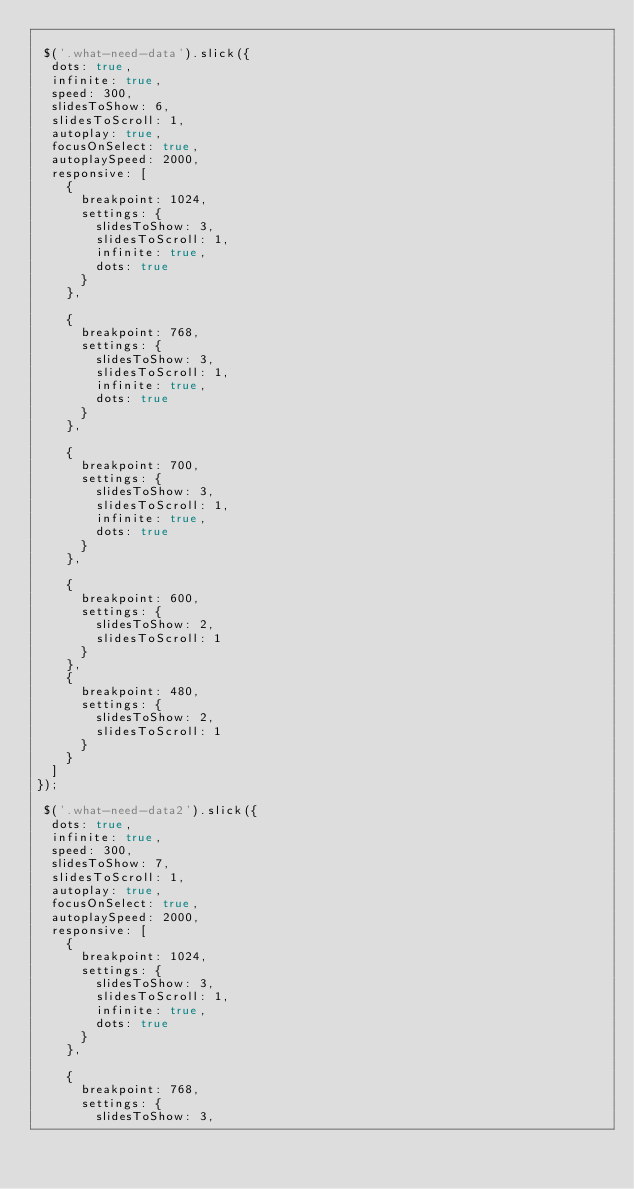Convert code to text. <code><loc_0><loc_0><loc_500><loc_500><_JavaScript_>
 $('.what-need-data').slick({
  dots: true,
  infinite: true,
  speed: 300,
  slidesToShow: 6,
  slidesToScroll: 1,
  autoplay: true,
  focusOnSelect: true,
  autoplaySpeed: 2000,
  responsive: [
    {
      breakpoint: 1024,
      settings: {
        slidesToShow: 3,
        slidesToScroll: 1,
        infinite: true,
        dots: true
      }
    },

    {
      breakpoint: 768,
      settings: {
        slidesToShow: 3,
        slidesToScroll: 1,
        infinite: true,
        dots: true
      }
    },

    {
      breakpoint: 700,
      settings: {
        slidesToShow: 3,
        slidesToScroll: 1,
        infinite: true,
        dots: true
      }
    },

    {
      breakpoint: 600,
      settings: {
        slidesToShow: 2,
        slidesToScroll: 1
      }
    },
    {
      breakpoint: 480,
      settings: {
        slidesToShow: 2,
        slidesToScroll: 1
      }
    }
  ]
});

 $('.what-need-data2').slick({
  dots: true,
  infinite: true,
  speed: 300,
  slidesToShow: 7,
  slidesToScroll: 1,
  autoplay: true,
  focusOnSelect: true,
  autoplaySpeed: 2000,
  responsive: [
    {
      breakpoint: 1024,
      settings: {
        slidesToShow: 3,
        slidesToScroll: 1,
        infinite: true,
        dots: true
      }
    },

    {
      breakpoint: 768,
      settings: {
        slidesToShow: 3,</code> 